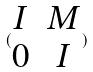Convert formula to latex. <formula><loc_0><loc_0><loc_500><loc_500>( \begin{matrix} I & M \\ 0 & I \end{matrix} )</formula> 